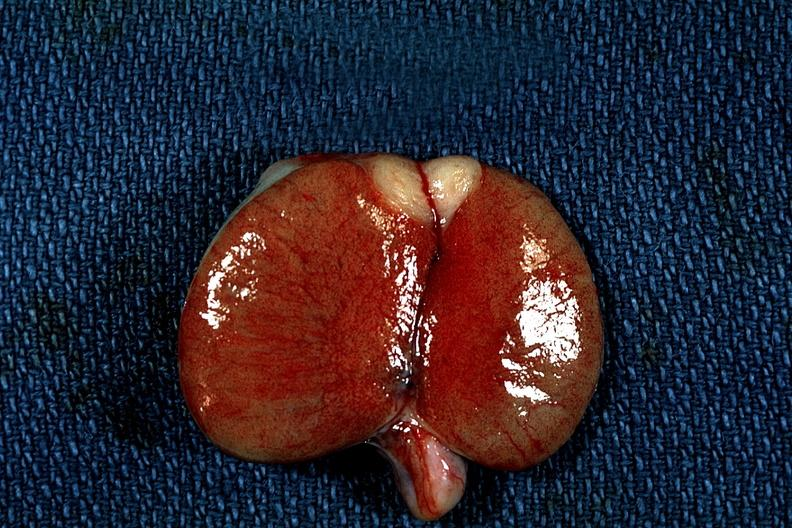what is present?
Answer the question using a single word or phrase. Metastatic carcinoma 